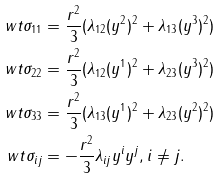Convert formula to latex. <formula><loc_0><loc_0><loc_500><loc_500>\ w t \sigma _ { 1 1 } & = \frac { r ^ { 2 } } 3 ( \lambda _ { 1 2 } ( y ^ { 2 } ) ^ { 2 } + \lambda _ { 1 3 } ( y ^ { 3 } ) ^ { 2 } ) \\ \ w t \sigma _ { 2 2 } & = \frac { r ^ { 2 } } 3 ( \lambda _ { 1 2 } ( y ^ { 1 } ) ^ { 2 } + \lambda _ { 2 3 } ( y ^ { 3 } ) ^ { 2 } ) \\ \ w t \sigma _ { 3 3 } & = \frac { r ^ { 2 } } 3 ( \lambda _ { 1 3 } ( y ^ { 1 } ) ^ { 2 } + \lambda _ { 2 3 } ( y ^ { 2 } ) ^ { 2 } ) \\ \ w t \sigma _ { i j } & = - \frac { r ^ { 2 } } 3 \lambda _ { i j } y ^ { i } y ^ { j } , \text {$i\neq j$} .</formula> 